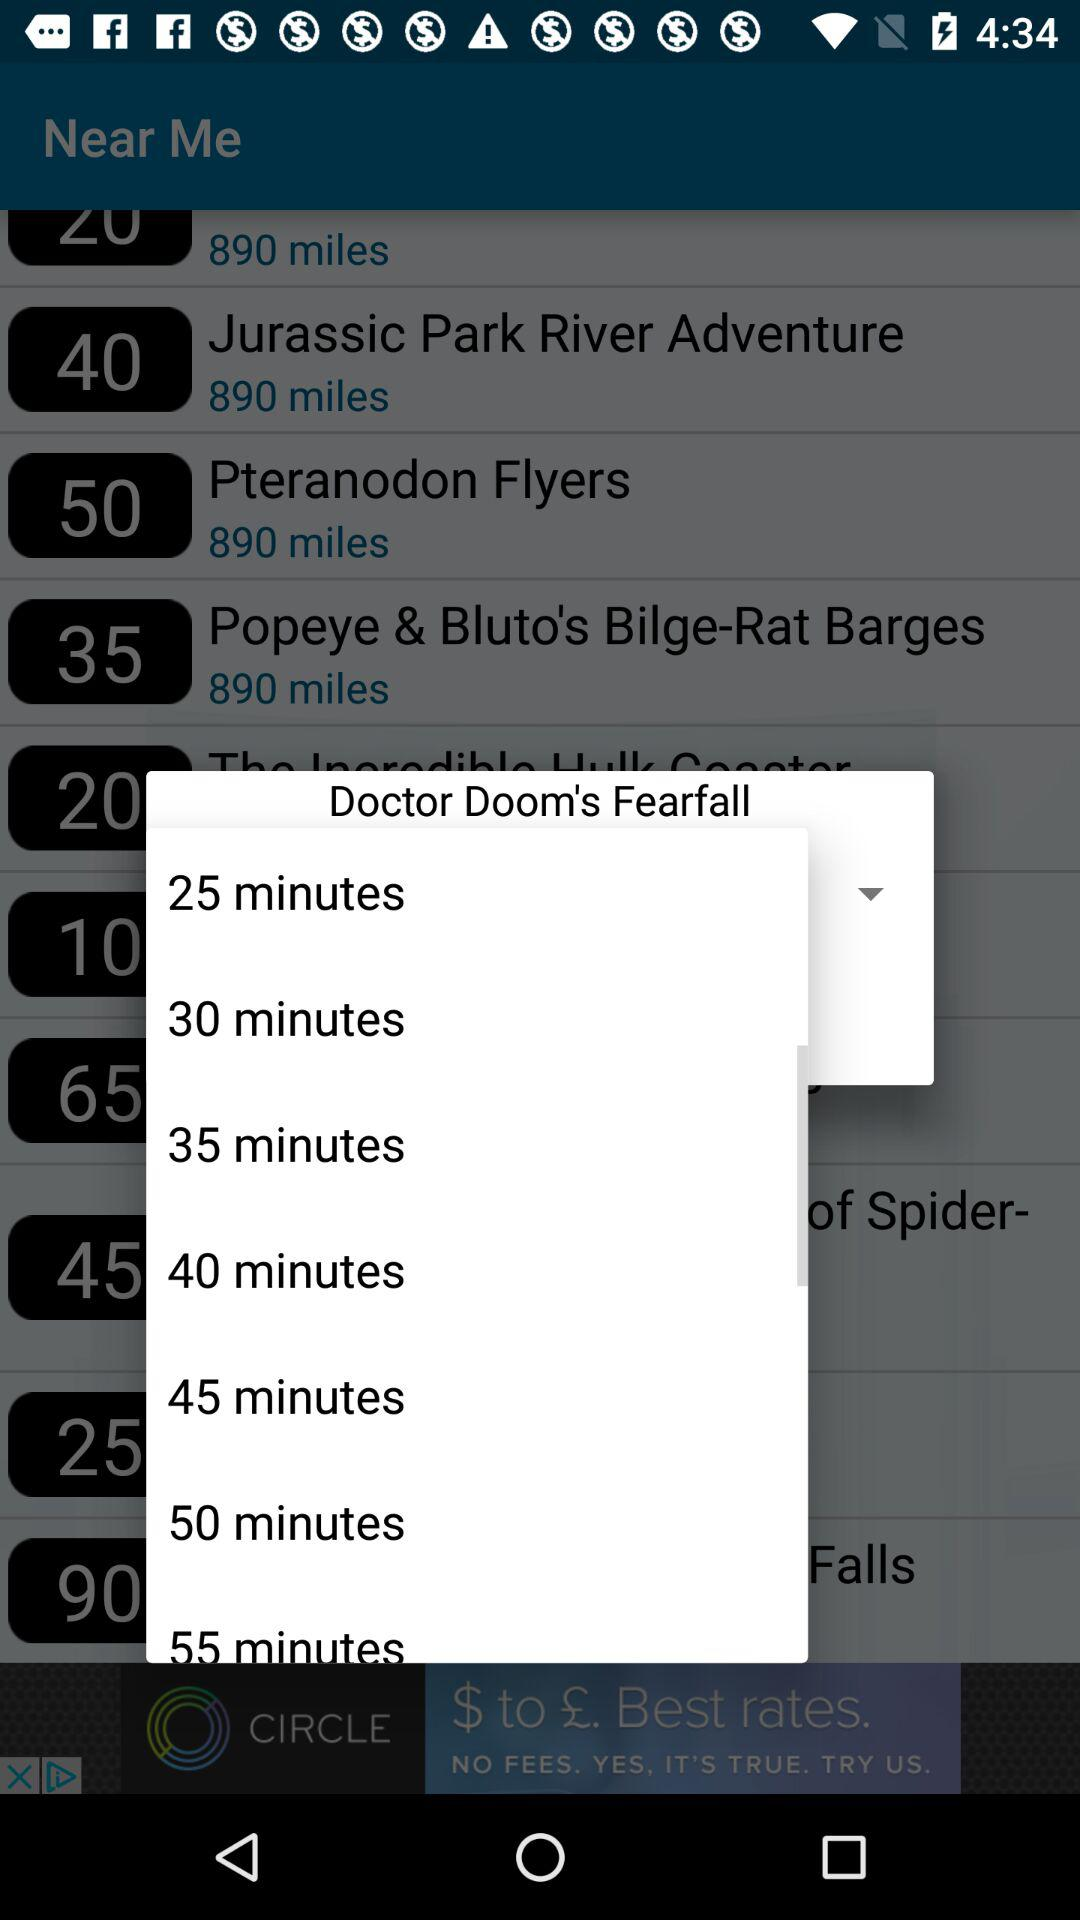How many minutes longer is the longest ride than the shortest ride?
Answer the question using a single word or phrase. 30 